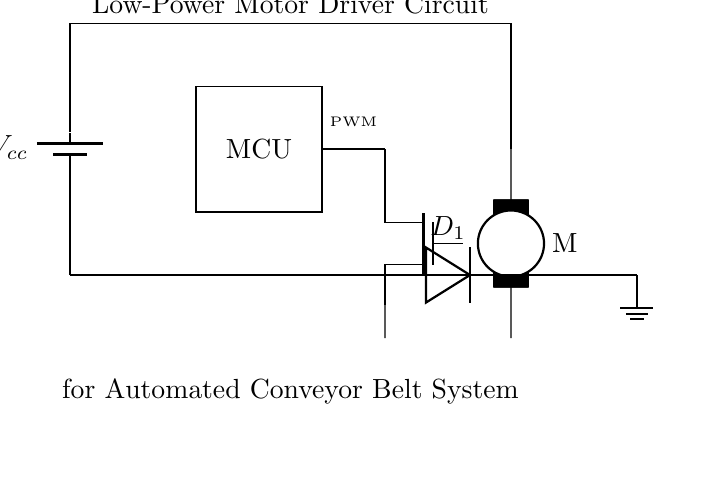What type of motor is used in this circuit? The circuit diagram includes a line that designates a motor, specifically labeled as an electromechanical motor, indicated by the symbol Telmech.
Answer: Electromechanical motor What component acts as the current switch in this circuit? The circuit shows a component labeled as 'mosfet,' which is a type of transistor used to control the current flow to the motor based on the PWM signal.
Answer: MOSFET What is the function of the diode in this circuit? The diode, marked as D1, serves to protect the circuit from back EMF generated when the motor is turned off, allowing current to flow in the reverse direction safely.
Answer: Flyback protection What voltage does the battery provide in this circuit? The battery in the circuit is labeled with Vcc, which suggests it supplies the necessary voltage to power the entire circuit, typically assumed to be around the levels of many low-power circuits.
Answer: Vcc How is the PWM signal generated in this circuit? The PWM signal is generated by the microcontroller (MCU) which is depicted in the circuit; it outputs the PWM signal to control the MOSFET's gate, regulating the motor's speed.
Answer: Microcontroller What is the primary application of this circuit? The diagram specifically states that the circuit is designed for an automated conveyor belt system, indicating its use in industrial automation.
Answer: Conveyor belt system What is the connection between the power supply and the motor? The circuit shows a direct connection from the power supply to the motor, ensuring that the motor receives the necessary voltage to operate when switched on via the MOSFET.
Answer: Direct connection 